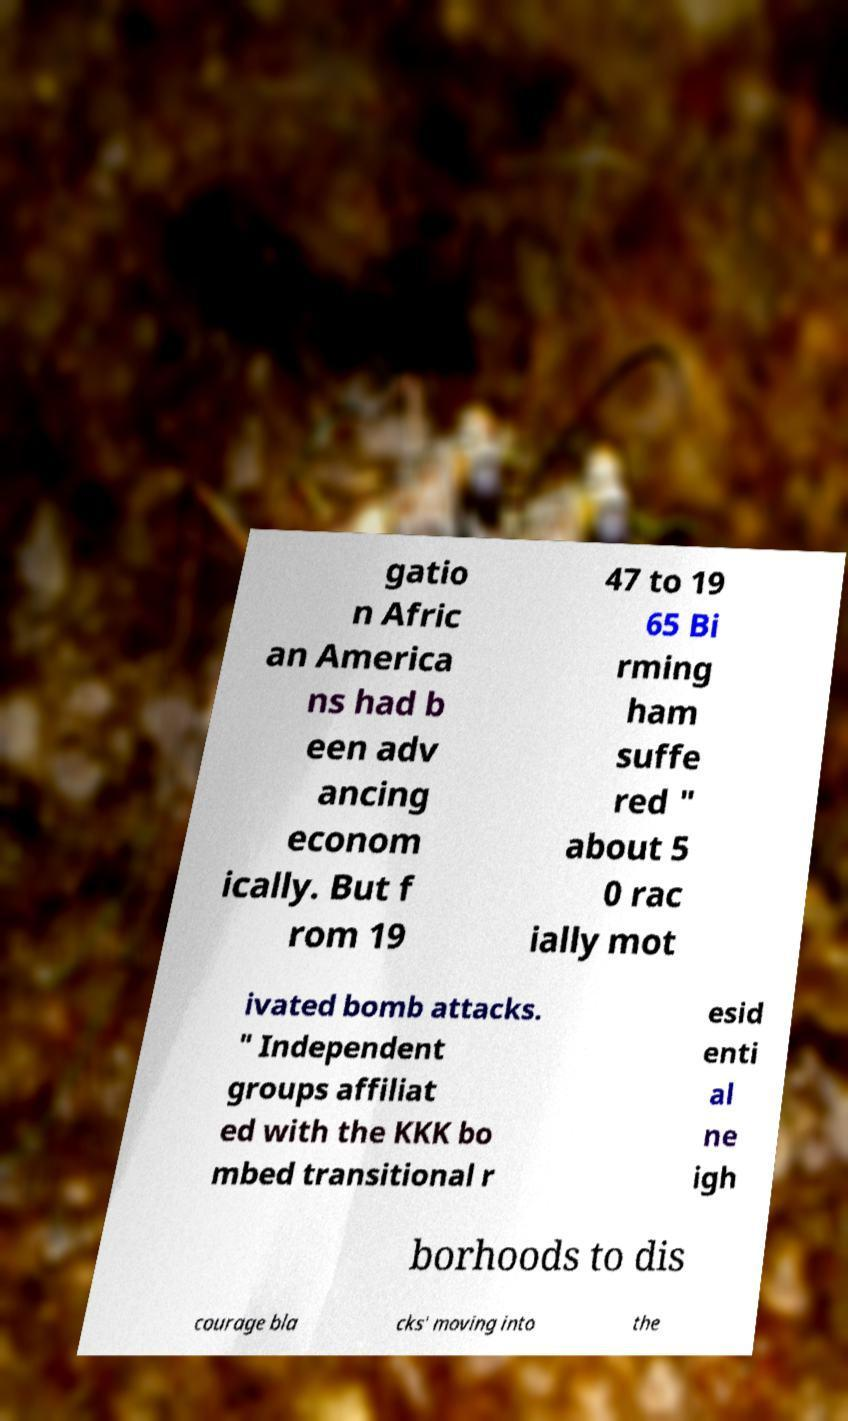Please read and relay the text visible in this image. What does it say? gatio n Afric an America ns had b een adv ancing econom ically. But f rom 19 47 to 19 65 Bi rming ham suffe red " about 5 0 rac ially mot ivated bomb attacks. " Independent groups affiliat ed with the KKK bo mbed transitional r esid enti al ne igh borhoods to dis courage bla cks' moving into the 